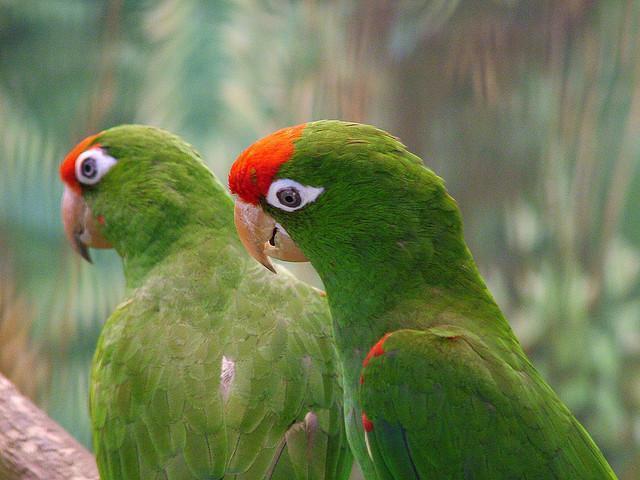How many bird are in the photo?
Give a very brief answer. 2. How many birds are visible?
Give a very brief answer. 2. 